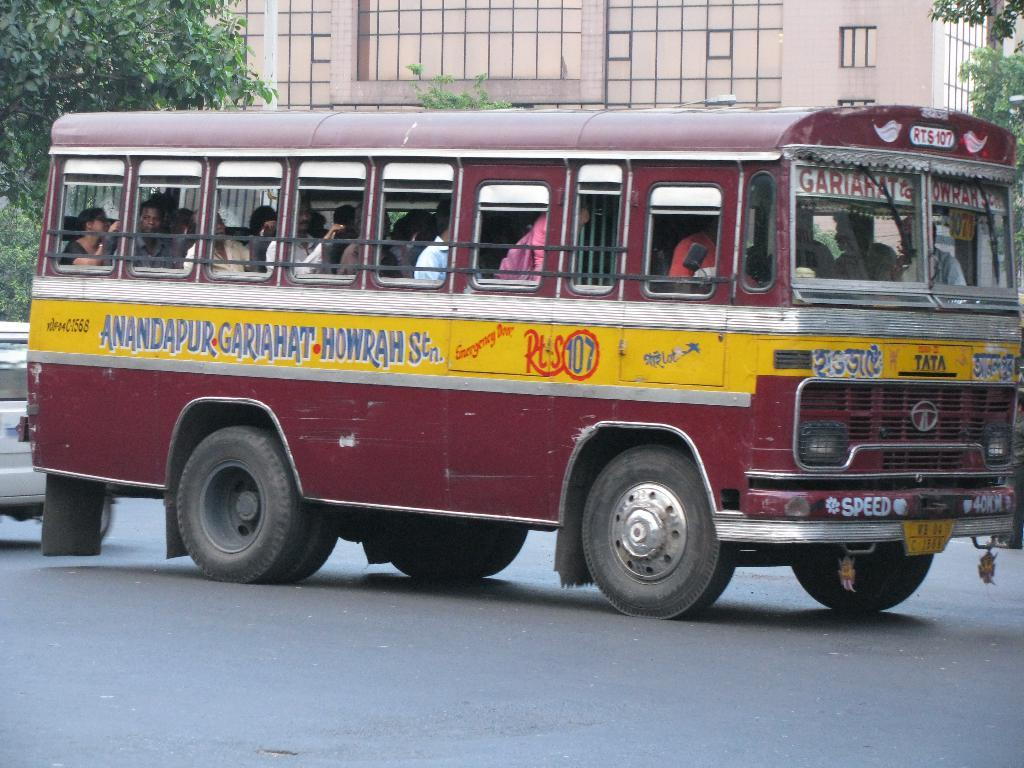<image>
Provide a brief description of the given image. A vintage bus that is maroon and yellow has the number RTS 107 above the windshield. 